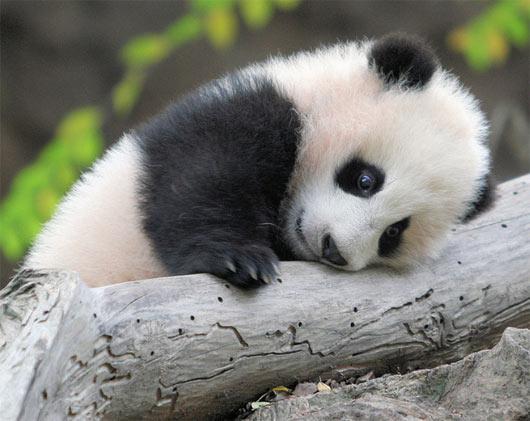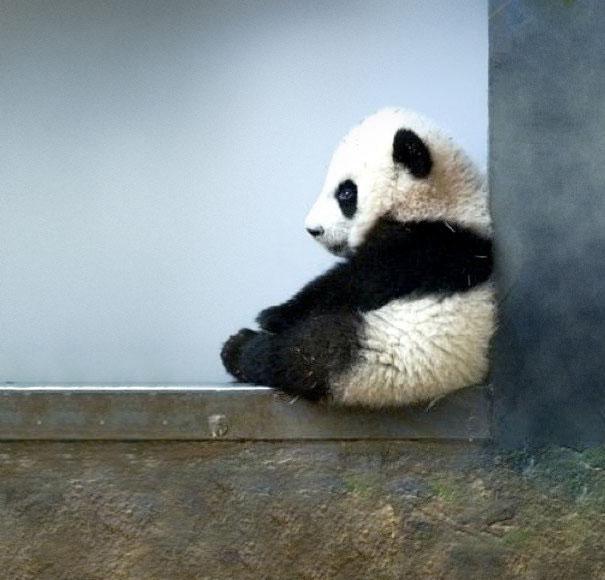The first image is the image on the left, the second image is the image on the right. For the images shown, is this caption "In one image, a panda's mouth is open" true? Answer yes or no. No. The first image is the image on the left, the second image is the image on the right. Given the left and right images, does the statement "In one image, a panda is sitting on something that is not wood." hold true? Answer yes or no. Yes. 